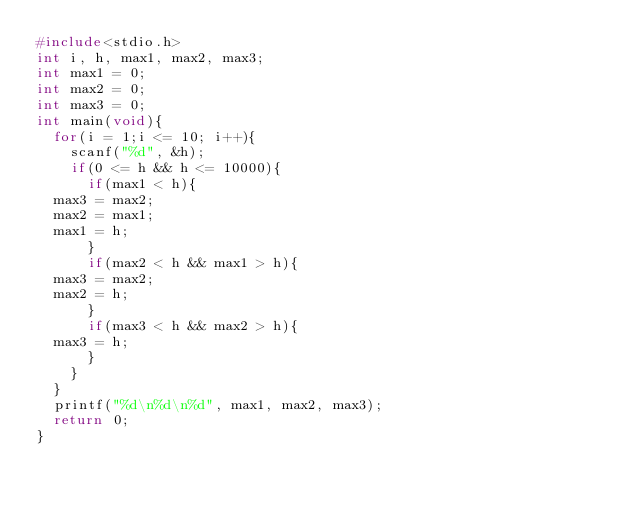<code> <loc_0><loc_0><loc_500><loc_500><_C_>#include<stdio.h>
int i, h, max1, max2, max3;
int max1 = 0;
int max2 = 0;
int max3 = 0;
int main(void){
  for(i = 1;i <= 10; i++){
    scanf("%d", &h);
    if(0 <= h && h <= 10000){
      if(max1 < h){
	max3 = max2;
	max2 = max1;
	max1 = h; 
      }
      if(max2 < h && max1 > h){
	max3 = max2;
	max2 = h;
      }
      if(max3 < h && max2 > h){
	max3 = h;
      }
    }
  }
  printf("%d\n%d\n%d", max1, max2, max3);
  return 0;
}</code> 